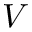Convert formula to latex. <formula><loc_0><loc_0><loc_500><loc_500>V</formula> 